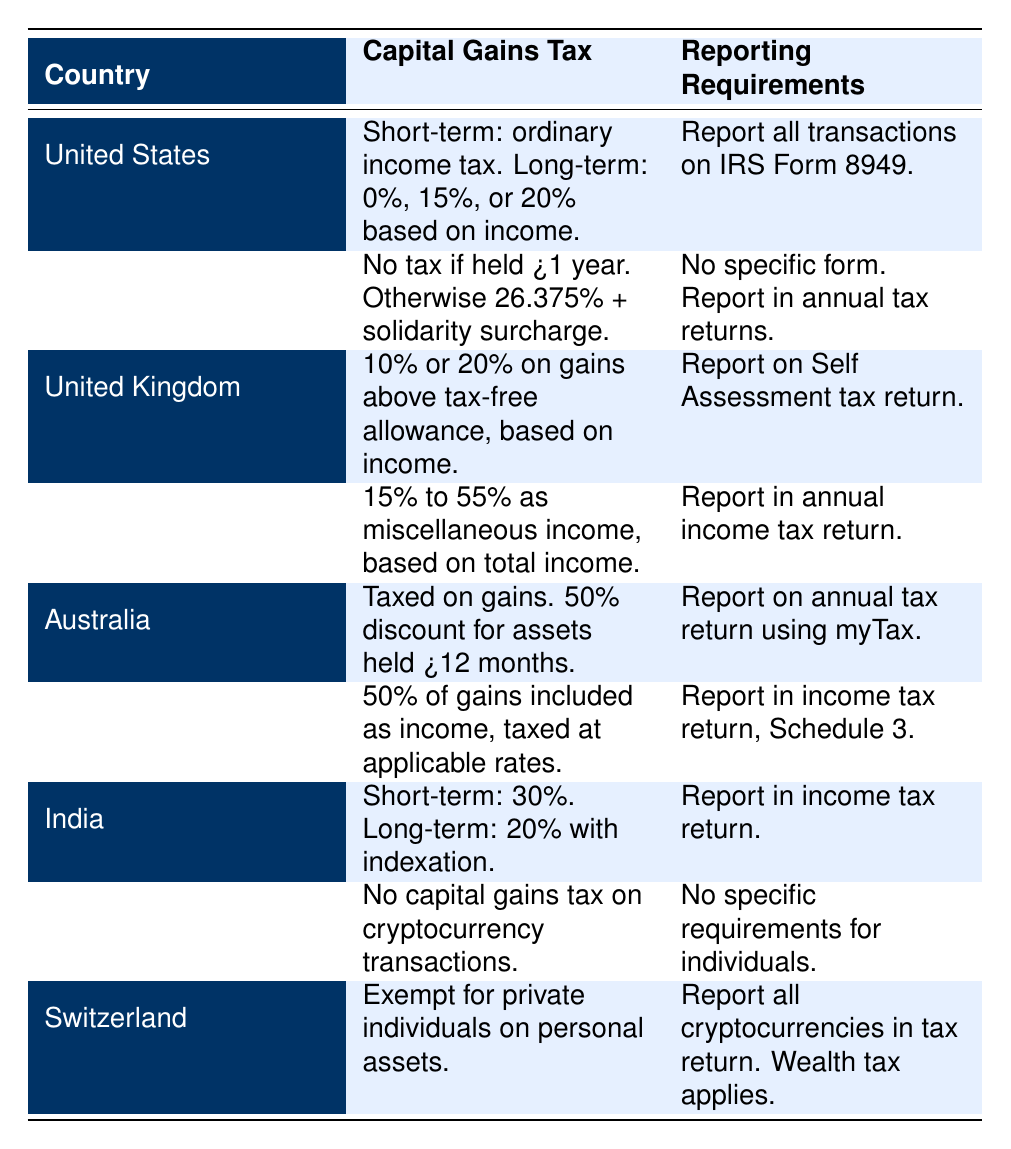What is the capital gains tax rate for short-term gains in India? India taxes short-term capital gains at a rate of 30%. This information is directly retrieved from the row for India in the table.
Answer: 30% Do holders in Germany need to report cryptocurrency transactions if held for more than one year? According to the table, Germany imposes no tax if the cryptocurrency is held for more than one year, but it does not specify a need for reporting in this case. Therefore, they are generally required to report in annual tax returns without a specific form.
Answer: Yes, but it’s included in annual tax returns Which country allows for a discount on capital gains tax for long-term holding? The table shows that Australia allows a 50% discount on capital gains tax for assets held for greater than 12 months.
Answer: Australia Is there a capital gains tax in Singapore for cryptocurrency transactions? The table indicates that Singapore does not impose any capital gains tax on cryptocurrency transactions, making this a yes or no question.
Answer: No What is the difference between short-term and long-term capital gains tax rates in the United States? The table specifies that short-term gains are taxed as ordinary income, while long-term gains are taxed at rates of 0%, 15%, or 20% depending on income level. Therefore, the difference is the type of tax applied (ordinary income vs. capital gains rate).
Answer: Short-term: ordinary income; long-term: 0%, 15%, or 20% How many countries do not impose a capital gains tax on cryptocurrency transactions? From the table, both Singapore and Switzerland do not impose capital gains tax. Counting them gives two countries.
Answer: 2 What is the highest possible capital gains tax rate listed in the table for any country? Upon reviewing the table, Japan has a capital gains tax range from 15% to 55%. Thus, the highest rate listed is 55%.
Answer: 55% In which country do individual holders not pay capital gains tax, but need to report for wealth tax? According to the table, Switzerland exempts private individuals from capital gains tax on personal assets but requires reporting for wealth tax purposes.
Answer: Switzerland Which country has the lowest tax on long-term capital gains? The table indicates that Germany has no tax on long-term capital gains if held for over one year, which is the lowest compared to others listed.
Answer: Germany What is the average capital gains tax rate for the countries listed in the table? The rates are varied: USA (20%), Germany (0%), UK (20%), Japan (55%), Australia (50%), Canada (50%), India (20%), Singapore (0%), Switzerland (0%). The sum of applicable rates (20 + 0 + 20 + 55 + 50 + 50 + 20 + 0 + 0) = 215. There are 9 entries, thus the average is 215/9 = 23.89 (rounded).
Answer: Approximately 23.89% 